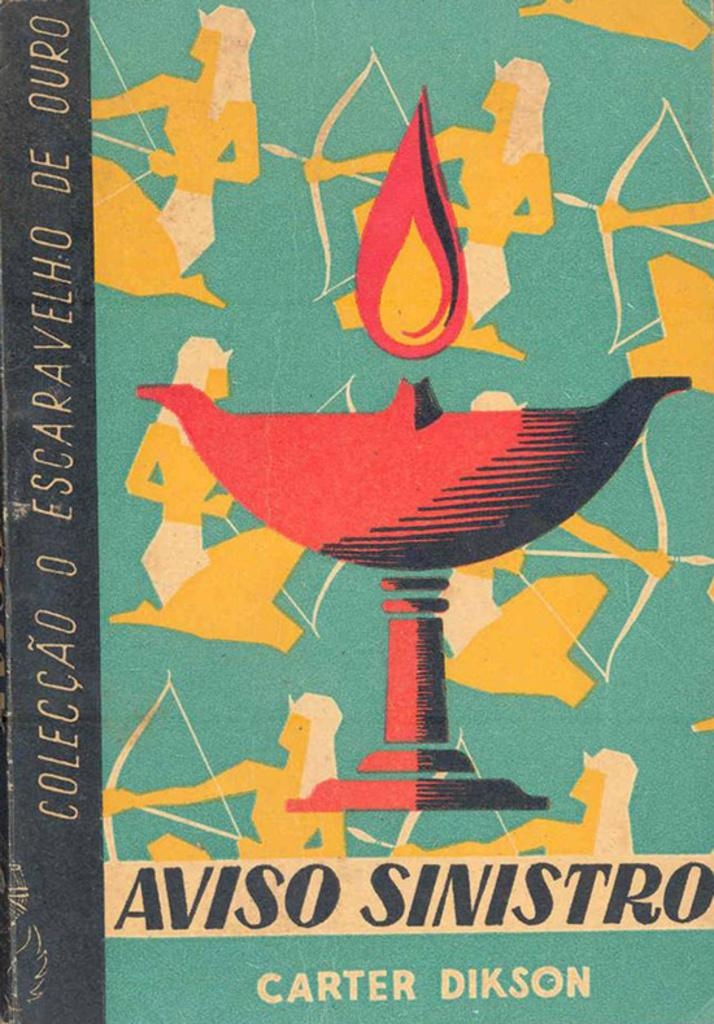<image>
Share a concise interpretation of the image provided. a book cover with egyptians holding arrows written by carter dikson 